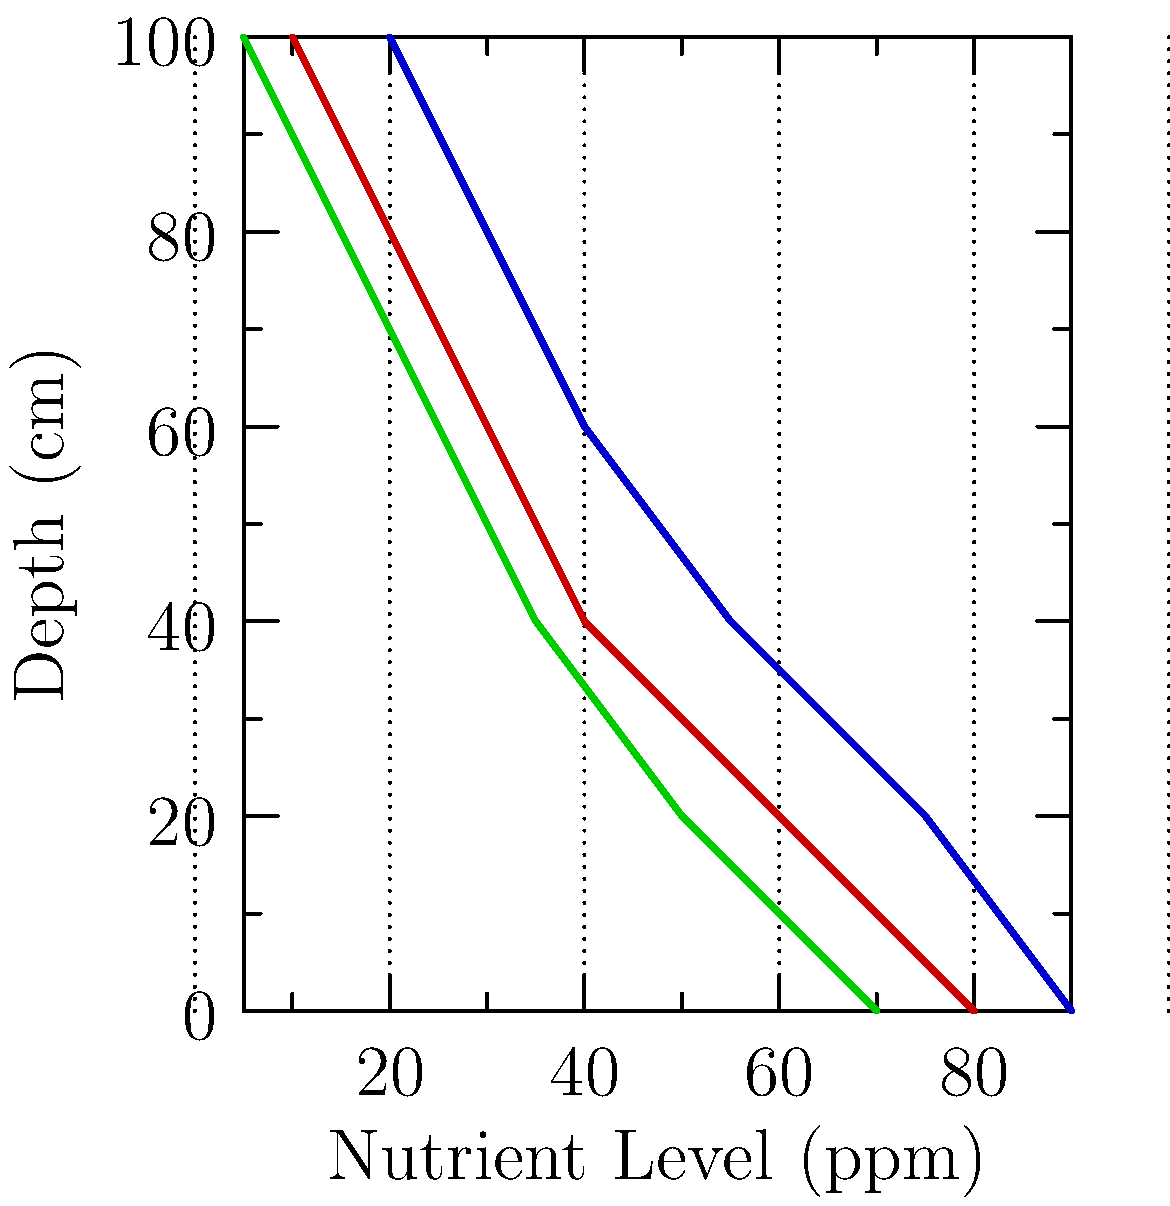Based on the color-coded soil profile diagram, which nutrient shows the highest concentration in the topsoil (0-20 cm) and maintains the highest levels throughout the soil profile? To determine which nutrient has the highest concentration in the topsoil and maintains the highest levels throughout the soil profile, we need to analyze the graph for each nutrient:

1. Identify the nutrients:
   - Red line: Nitrogen
   - Green line: Phosphorus
   - Blue line: Potassium

2. Compare topsoil (0-20 cm) concentrations:
   - Nitrogen: Approximately 80 ppm
   - Phosphorus: Approximately 70 ppm
   - Potassium: Approximately 90 ppm

3. Analyze the nutrient levels throughout the profile:
   - Nitrogen: Decreases rapidly with depth
   - Phosphorus: Decreases steadily with depth
   - Potassium: Decreases more gradually with depth

4. Compare the nutrient levels at various depths:
   - At 40 cm: Potassium > Nitrogen > Phosphorus
   - At 60 cm: Potassium > Nitrogen > Phosphorus
   - At 80 cm: Potassium > Nitrogen > Phosphorus
   - At 100 cm: Potassium > Nitrogen > Phosphorus

5. Conclusion:
   Potassium (blue line) shows the highest concentration in the topsoil (0-20 cm) at approximately 90 ppm and maintains the highest levels throughout the entire soil profile compared to nitrogen and phosphorus.
Answer: Potassium 